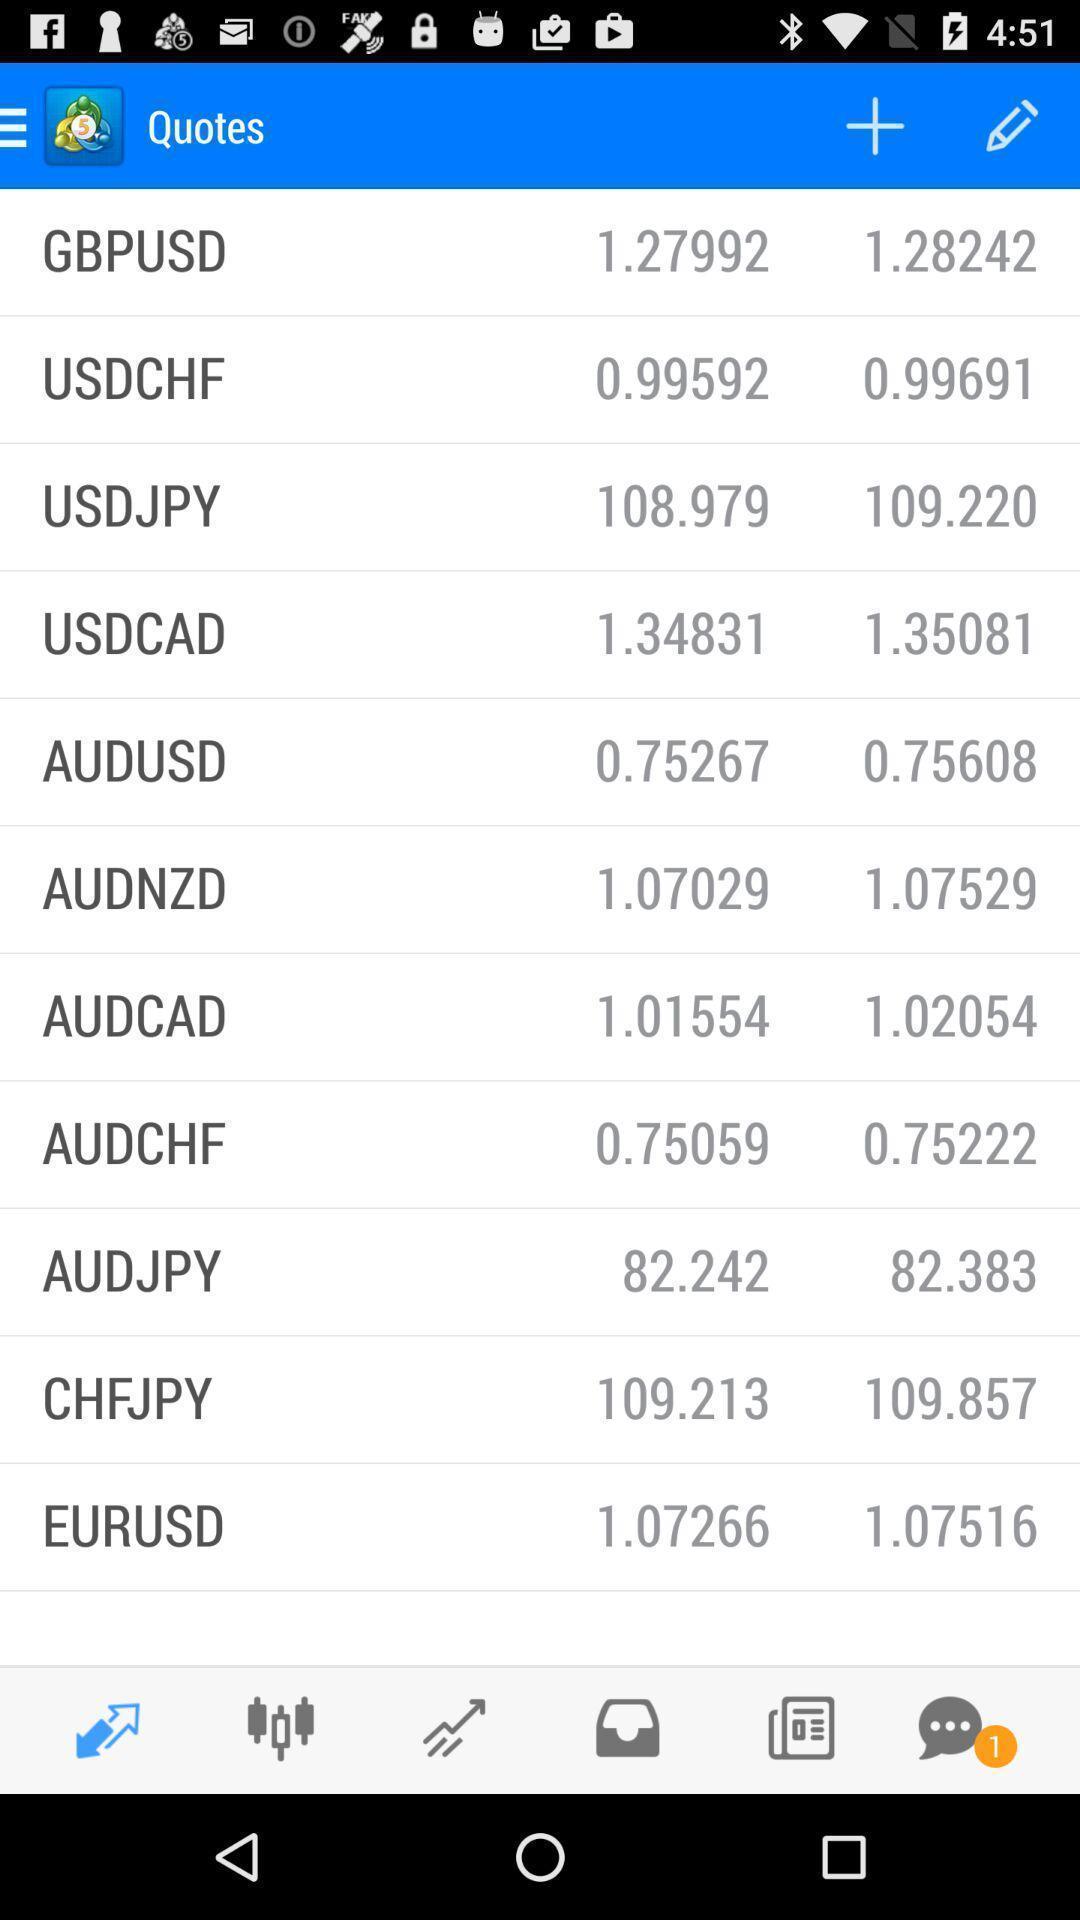Provide a detailed account of this screenshot. Screen page displaying various options. 